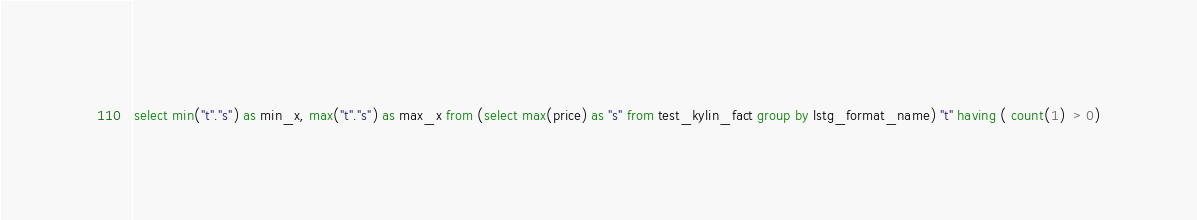Convert code to text. <code><loc_0><loc_0><loc_500><loc_500><_SQL_>select min("t"."s") as min_x, max("t"."s") as max_x from (select max(price) as "s" from test_kylin_fact group by lstg_format_name) "t" having ( count(1)  > 0)</code> 